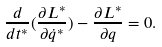<formula> <loc_0><loc_0><loc_500><loc_500>\frac { d } { d t ^ { * } } ( \frac { \partial L ^ { * } } { \partial \dot { q } ^ { * } } ) - \frac { \partial L ^ { * } } { \partial q } = 0 .</formula> 